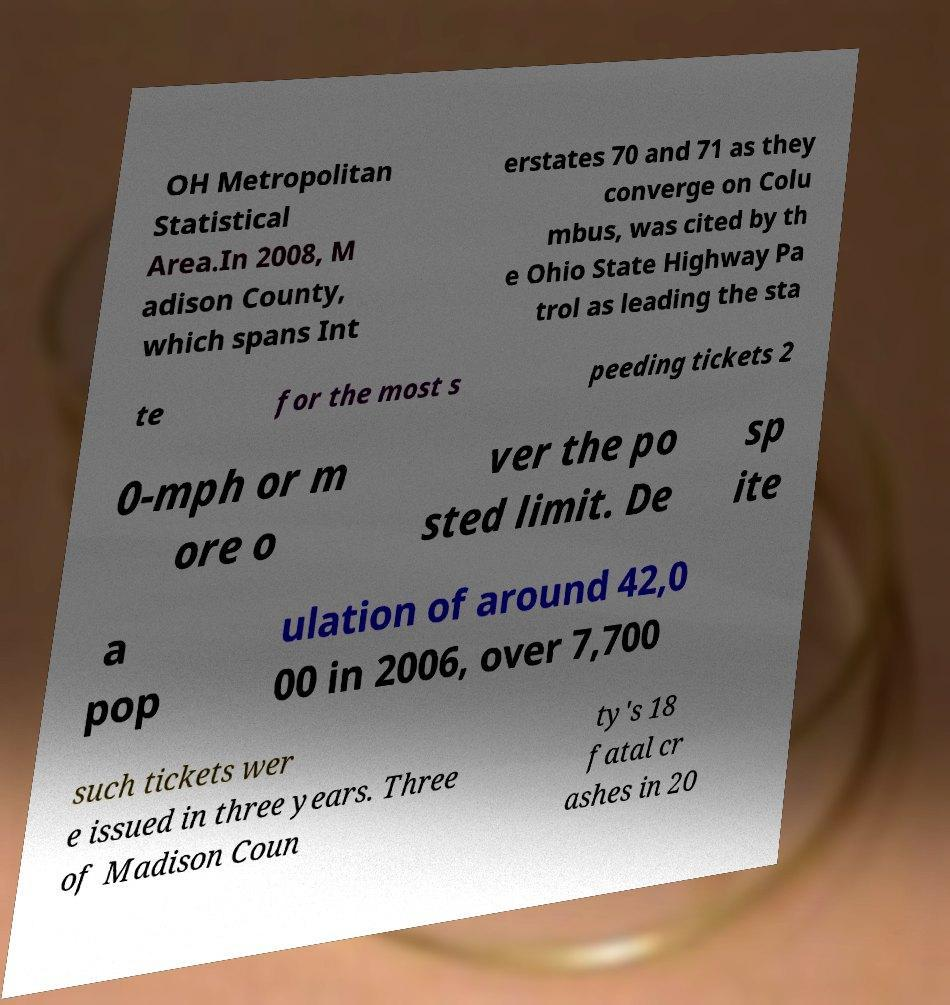Could you extract and type out the text from this image? OH Metropolitan Statistical Area.In 2008, M adison County, which spans Int erstates 70 and 71 as they converge on Colu mbus, was cited by th e Ohio State Highway Pa trol as leading the sta te for the most s peeding tickets 2 0-mph or m ore o ver the po sted limit. De sp ite a pop ulation of around 42,0 00 in 2006, over 7,700 such tickets wer e issued in three years. Three of Madison Coun ty's 18 fatal cr ashes in 20 